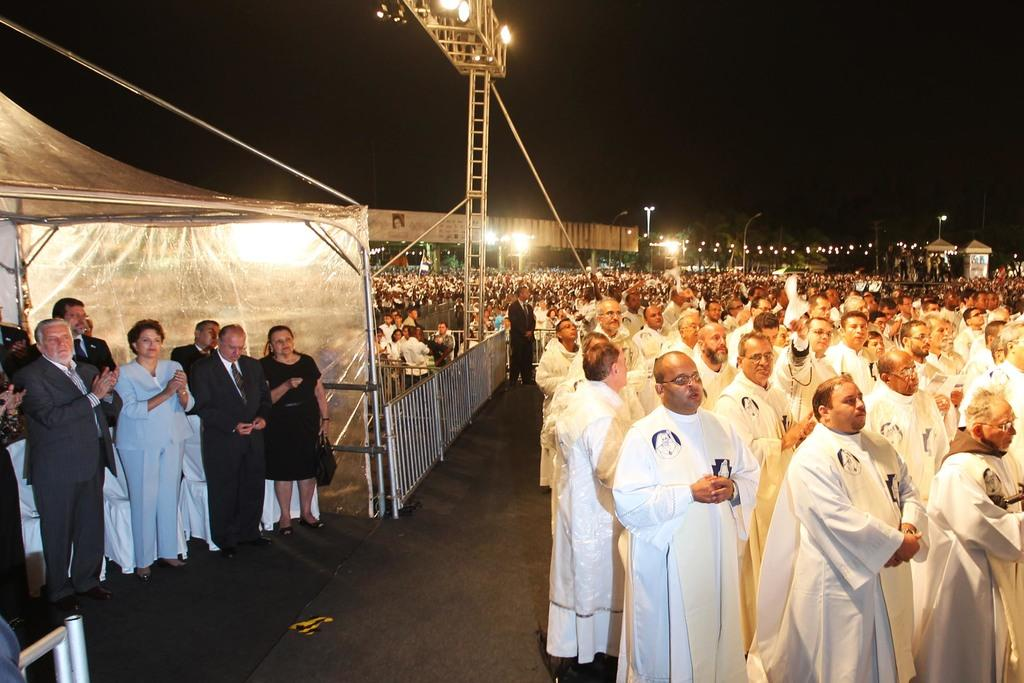What are the people in the image doing? The people in the image are standing on the ground. What is attached to the road in the image? Lights are attached to the road in the image. What type of barrier is present in the image? There is a fence in the image. What is the purpose of the board in the image? The purpose of the board in the image is not clear, but it might be used for signage or display. What type of lighting is visible in the image? A street light is visible in the image. What type of structure is present in the image? Pillars are present in the image. What is the color of the background in the image? The background of the image is dark. What type of straw is being used to comb the hair of the person in the image? There is no person or hair combing activity present in the image. What type of lumber is being used to build the fence in the image? There is no lumber or fence construction activity present in the image. 